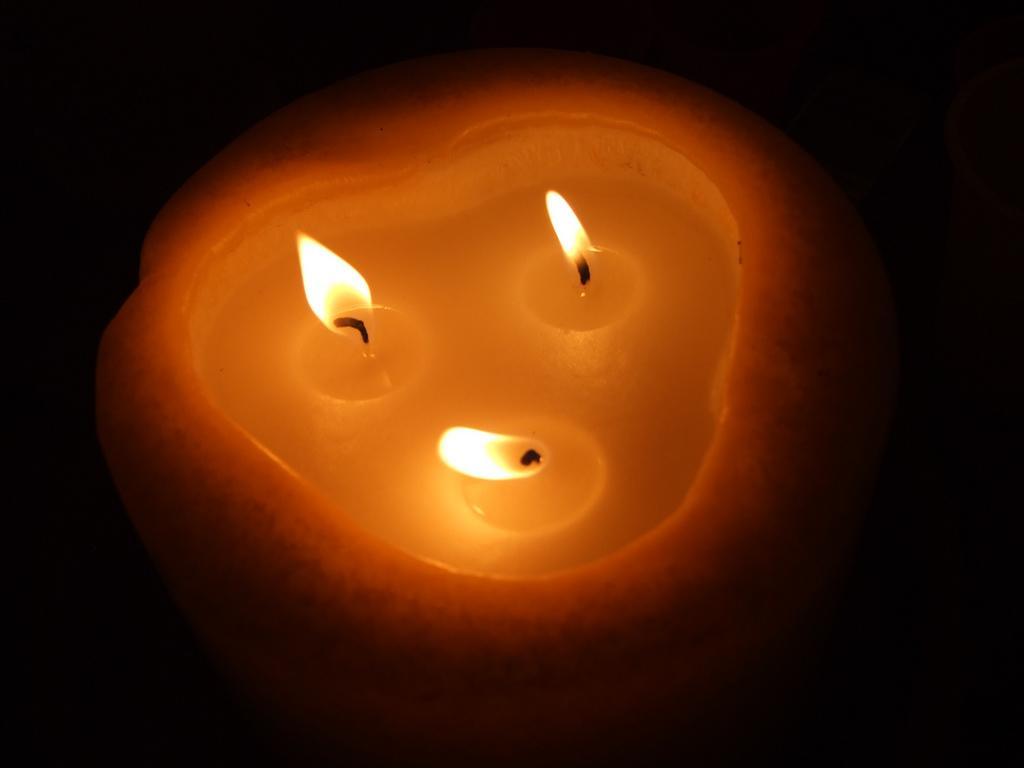What is the main object in the image? There is an illuminated candle in the image. What color is the background of the image? The background of the image is black. What type of sweater is the candle wearing in the image? There is no sweater present in the image, as candles do not wear clothing. How does the candle burn its nose in the image? There is no nose present in the image, as candles do not have noses. 